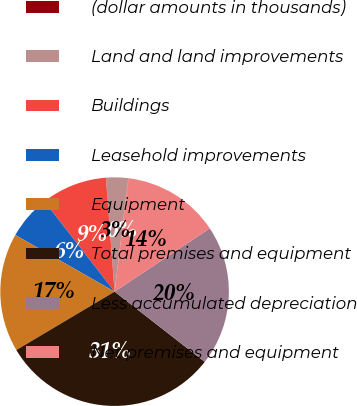<chart> <loc_0><loc_0><loc_500><loc_500><pie_chart><fcel>(dollar amounts in thousands)<fcel>Land and land improvements<fcel>Buildings<fcel>Leasehold improvements<fcel>Equipment<fcel>Total premises and equipment<fcel>Less accumulated depreciation<fcel>Net premises and equipment<nl><fcel>0.04%<fcel>3.13%<fcel>9.31%<fcel>6.22%<fcel>16.79%<fcel>30.93%<fcel>19.87%<fcel>13.7%<nl></chart> 